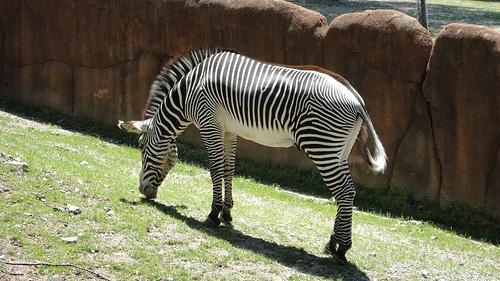How many zebras?
Give a very brief answer. 1. 